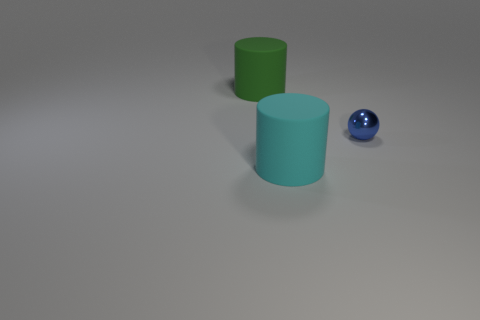Subtract all balls. How many objects are left? 2 Subtract 1 cylinders. How many cylinders are left? 1 Subtract all cyan cylinders. Subtract all cyan balls. How many cylinders are left? 1 Subtract all yellow blocks. How many cyan cylinders are left? 1 Subtract all rubber spheres. Subtract all cyan objects. How many objects are left? 2 Add 3 blue metal things. How many blue metal things are left? 4 Add 2 green rubber cylinders. How many green rubber cylinders exist? 3 Add 3 small blue shiny objects. How many objects exist? 6 Subtract all green cylinders. How many cylinders are left? 1 Subtract 0 green cubes. How many objects are left? 3 